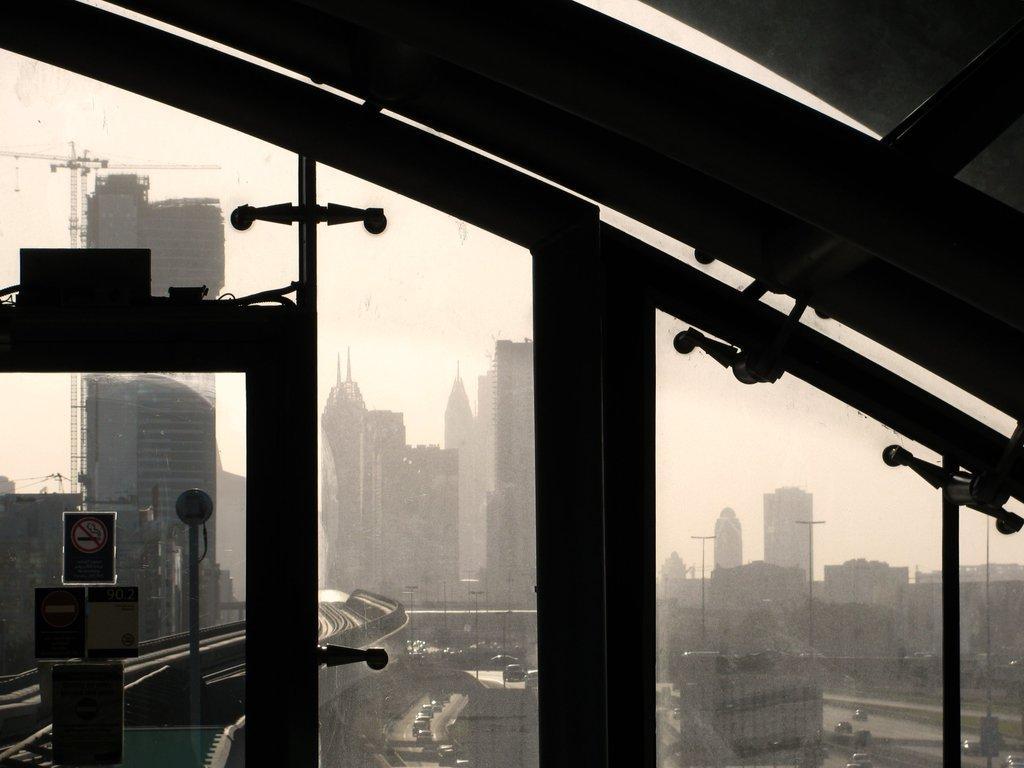Please provide a concise description of this image. In this picture we can see poster and glass, through this glass we can see poles, board, buildings, vehicles, crane and sky. 